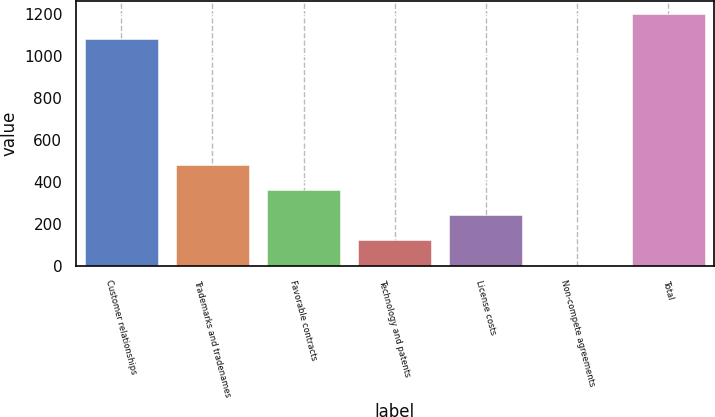<chart> <loc_0><loc_0><loc_500><loc_500><bar_chart><fcel>Customer relationships<fcel>Trademarks and tradenames<fcel>Favorable contracts<fcel>Technology and patents<fcel>License costs<fcel>Non-compete agreements<fcel>Total<nl><fcel>1079.8<fcel>479.54<fcel>360.08<fcel>121.16<fcel>240.62<fcel>1.7<fcel>1199.26<nl></chart> 